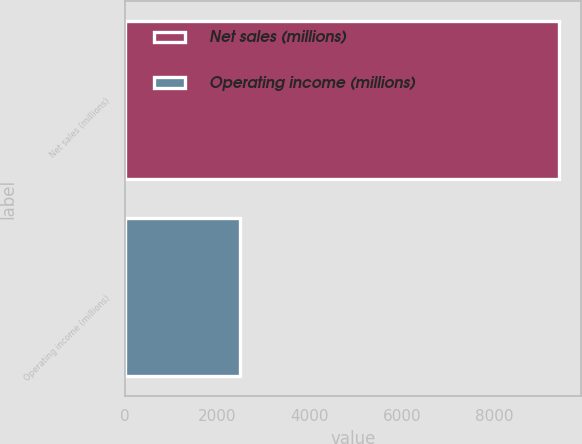Convert chart. <chart><loc_0><loc_0><loc_500><loc_500><bar_chart><fcel>Net sales (millions)<fcel>Operating income (millions)<nl><fcel>9418<fcel>2487<nl></chart> 